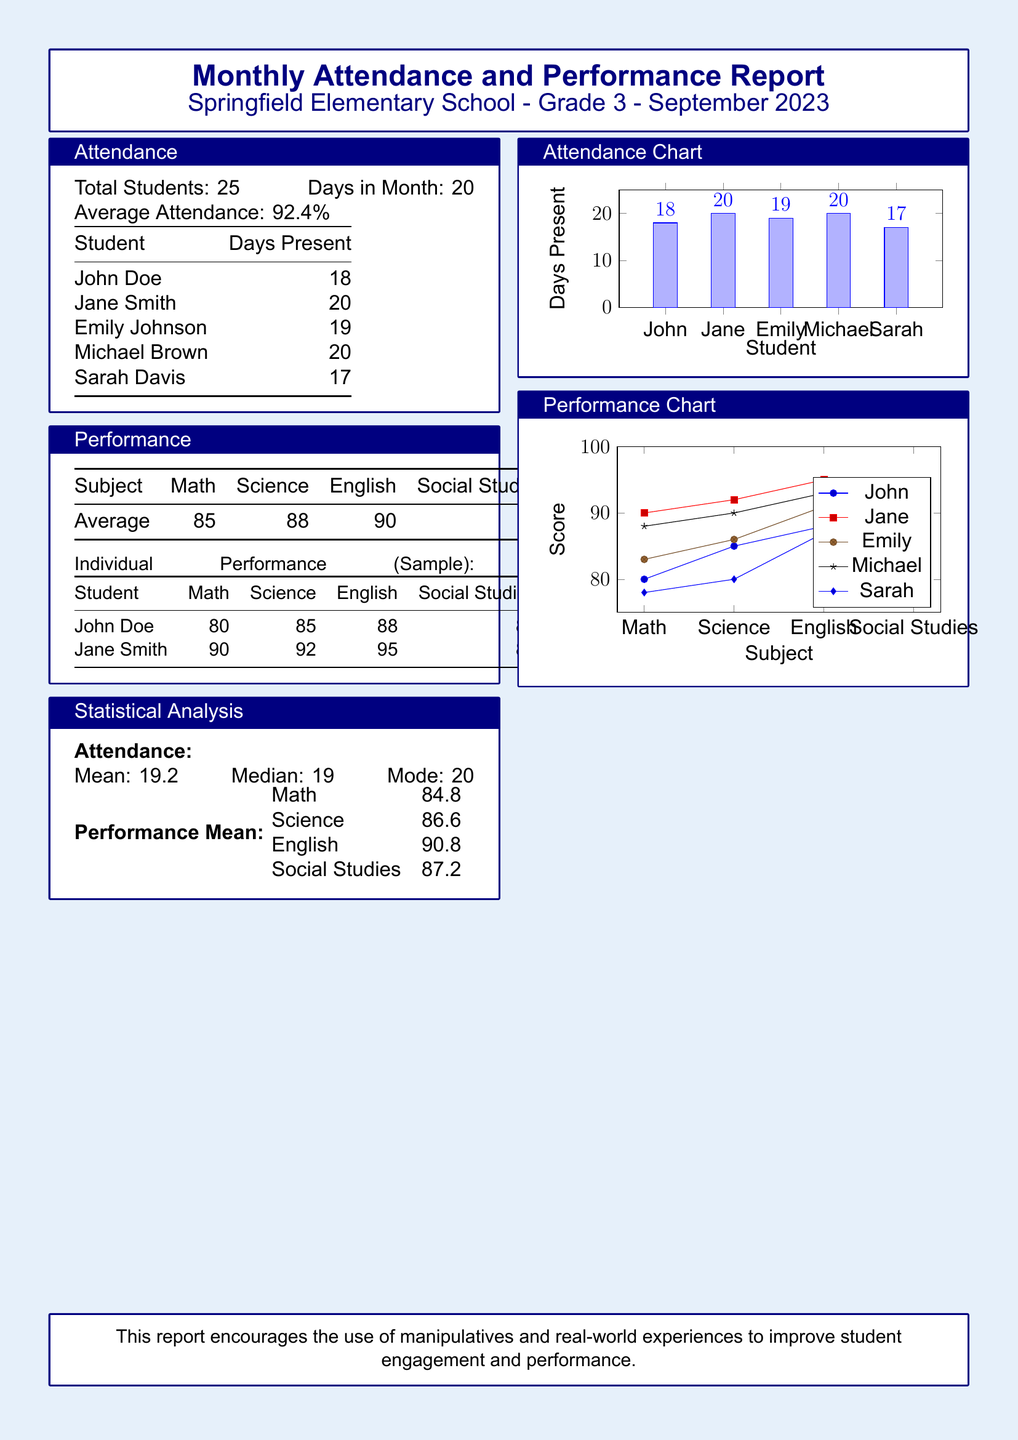What is the total number of students in Grade 3? The document states that there are 25 students enrolled in Grade 3 at Springfield Elementary School.
Answer: 25 What is the average attendance percentage for September 2023? The average attendance percentage listed in the attendance box shows that it is 92.4%.
Answer: 92.4% How many days was Jane Smith present? The table under attendance shows that Jane Smith was present for 20 days.
Answer: 20 What is the average score for English? The performance table indicates that the average score for English among the students is 90.
Answer: 90 What is the median attendance days? The statistical analysis section indicates that the median attendance days were 19.
Answer: 19 Which subject had the highest average score? Looking at the performance average, English has the highest average score of 90.
Answer: English How many students scored 80 or below in Math? The individual performance table shows that only one student, John Doe, scored below 80 in Math.
Answer: 1 What is the highest score in Science? The maximum score in the individual performance table for Science is 92 from Jane Smith.
Answer: 92 What type of graphics is used to represent attendance? The attendance data is represented using a bar chart in the report.
Answer: Bar chart 